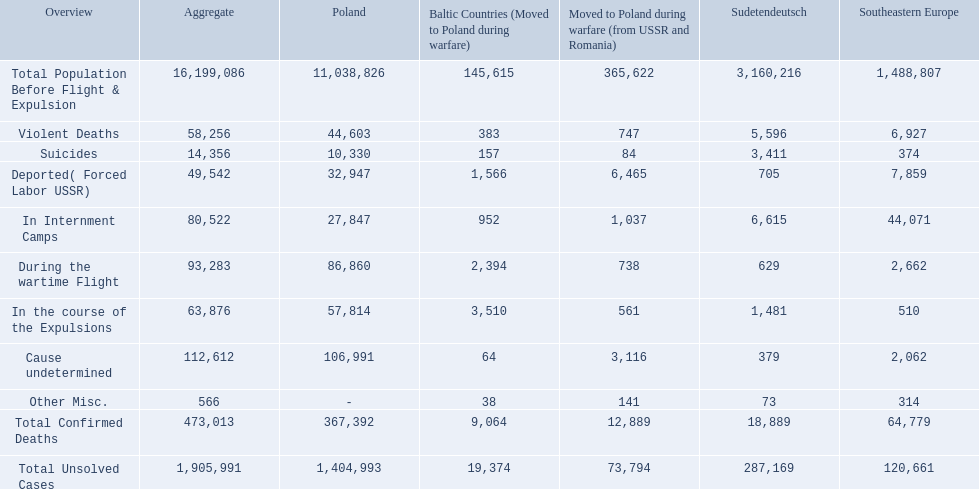How many total confirmed deaths were there in the baltic states? 9,064. How many deaths had an undetermined cause? 64. How many deaths in that region were miscellaneous? 38. Were there more deaths from an undetermined cause or that were listed as miscellaneous? Cause undetermined. 